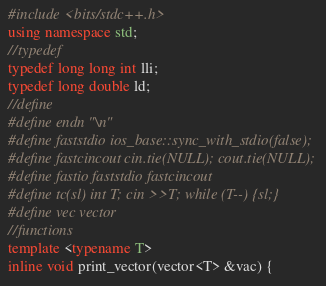Convert code to text. <code><loc_0><loc_0><loc_500><loc_500><_C++_>#include <bits/stdc++.h>
using namespace std;
//typedef
typedef long long int lli;
typedef long double ld;
//define
#define endn "\n"
#define faststdio ios_base::sync_with_stdio(false);
#define fastcincout cin.tie(NULL); cout.tie(NULL);
#define fastio faststdio fastcincout
#define tc(sl) int T; cin >>T; while (T--) {sl;}
#define vec vector
//functions
template <typename T>
inline void print_vector(vector<T> &vac) {</code> 